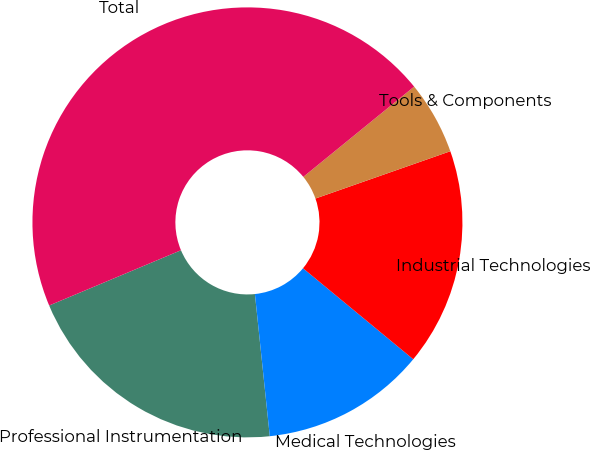<chart> <loc_0><loc_0><loc_500><loc_500><pie_chart><fcel>Professional Instrumentation<fcel>Medical Technologies<fcel>Industrial Technologies<fcel>Tools & Components<fcel>Total<nl><fcel>20.34%<fcel>12.36%<fcel>16.35%<fcel>5.51%<fcel>45.44%<nl></chart> 